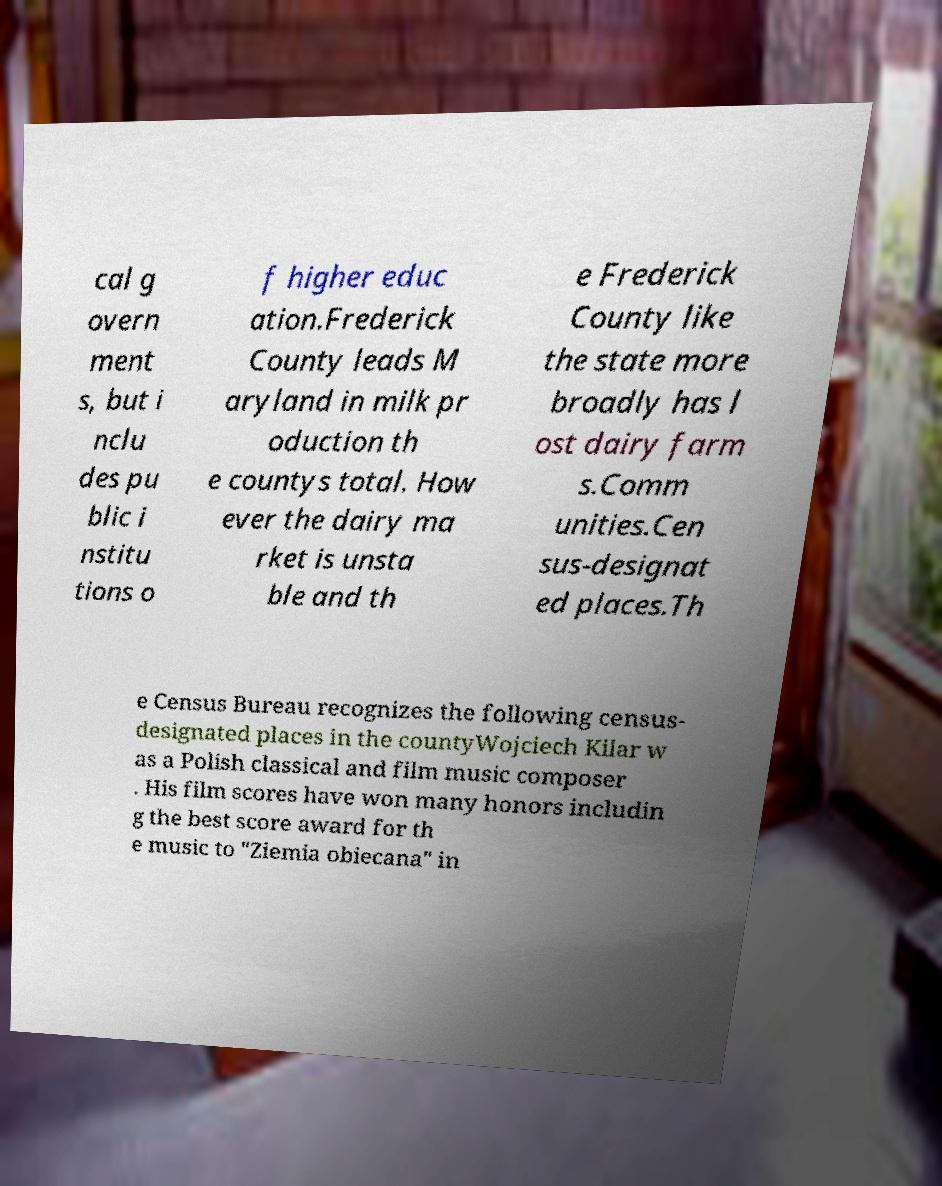Could you extract and type out the text from this image? cal g overn ment s, but i nclu des pu blic i nstitu tions o f higher educ ation.Frederick County leads M aryland in milk pr oduction th e countys total. How ever the dairy ma rket is unsta ble and th e Frederick County like the state more broadly has l ost dairy farm s.Comm unities.Cen sus-designat ed places.Th e Census Bureau recognizes the following census- designated places in the countyWojciech Kilar w as a Polish classical and film music composer . His film scores have won many honors includin g the best score award for th e music to "Ziemia obiecana" in 